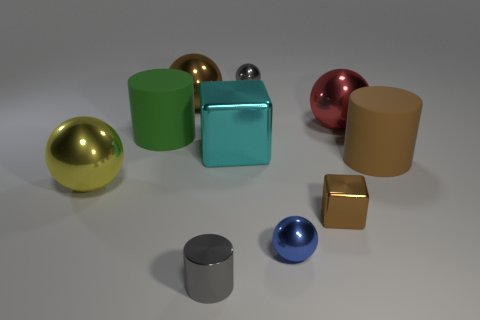What materials do the objects in the image seem to be made of? The objects in the image appear to have varying materials based on their surfaces: the gold and pink objects have a reflective metallic finish, the green, cyan, and blue objects seem to have a matte finish, the brown object looks like polished wood, and the gray cylinder and the golden cube might be made of either matte painted metal or a plastic material with a semi-reflective surface. 